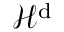<formula> <loc_0><loc_0><loc_500><loc_500>\mathcal { H } ^ { d }</formula> 